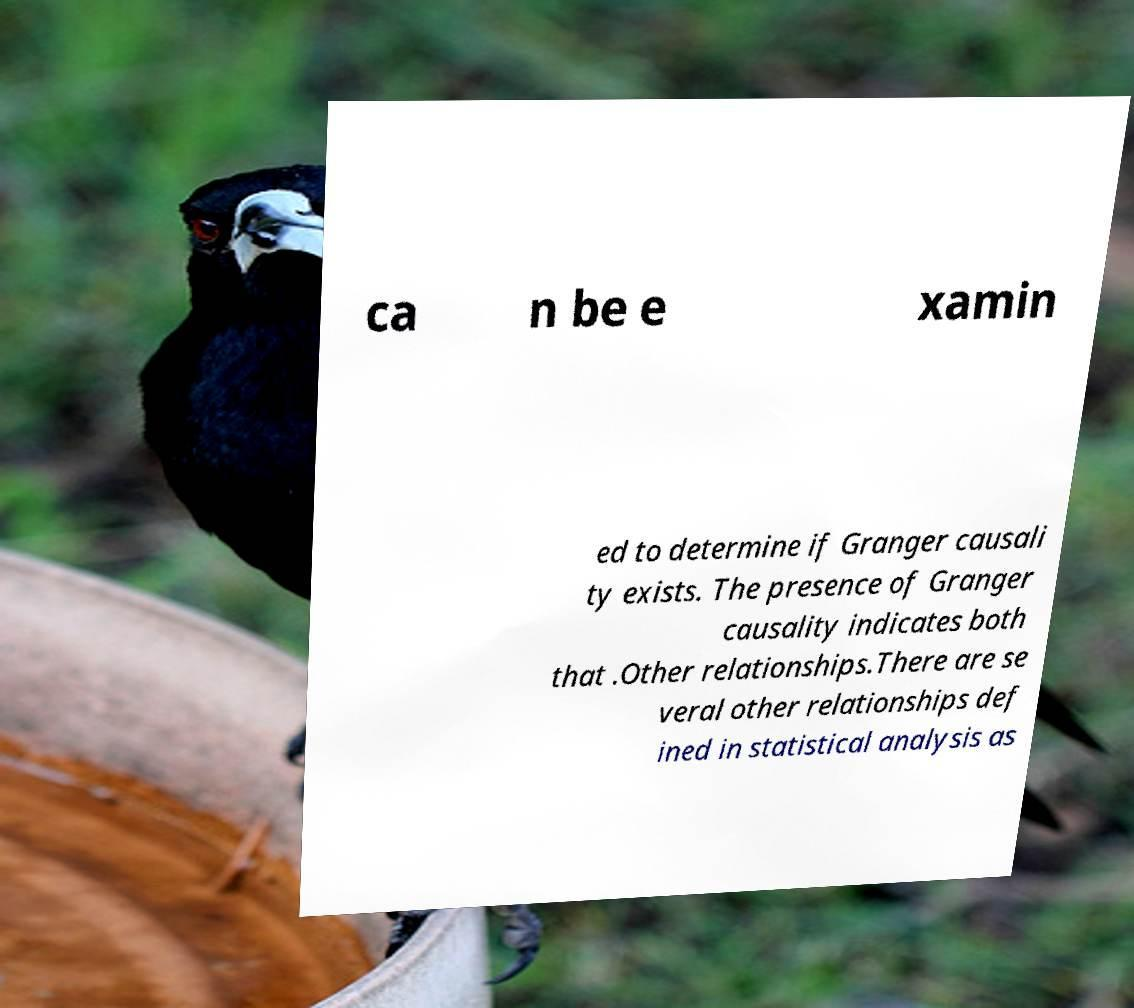What messages or text are displayed in this image? I need them in a readable, typed format. ca n be e xamin ed to determine if Granger causali ty exists. The presence of Granger causality indicates both that .Other relationships.There are se veral other relationships def ined in statistical analysis as 